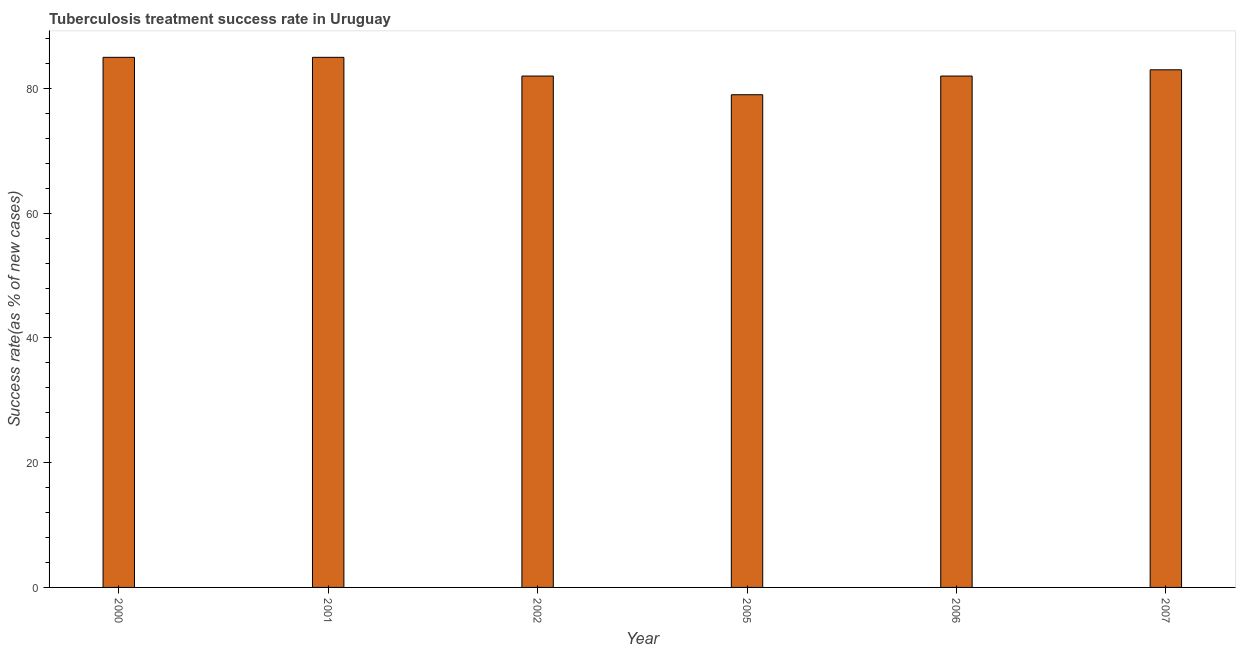Does the graph contain grids?
Provide a succinct answer. No. What is the title of the graph?
Keep it short and to the point. Tuberculosis treatment success rate in Uruguay. What is the label or title of the X-axis?
Offer a very short reply. Year. What is the label or title of the Y-axis?
Make the answer very short. Success rate(as % of new cases). What is the tuberculosis treatment success rate in 2007?
Provide a succinct answer. 83. Across all years, what is the maximum tuberculosis treatment success rate?
Your answer should be compact. 85. Across all years, what is the minimum tuberculosis treatment success rate?
Offer a very short reply. 79. In which year was the tuberculosis treatment success rate maximum?
Your answer should be compact. 2000. What is the sum of the tuberculosis treatment success rate?
Provide a short and direct response. 496. What is the average tuberculosis treatment success rate per year?
Your response must be concise. 82. What is the median tuberculosis treatment success rate?
Your answer should be very brief. 82.5. Is the tuberculosis treatment success rate in 2002 less than that in 2007?
Offer a terse response. Yes. Is the difference between the tuberculosis treatment success rate in 2001 and 2005 greater than the difference between any two years?
Make the answer very short. Yes. What is the difference between the highest and the second highest tuberculosis treatment success rate?
Keep it short and to the point. 0. How many bars are there?
Provide a succinct answer. 6. Are all the bars in the graph horizontal?
Ensure brevity in your answer.  No. How many years are there in the graph?
Your answer should be compact. 6. What is the difference between two consecutive major ticks on the Y-axis?
Your response must be concise. 20. Are the values on the major ticks of Y-axis written in scientific E-notation?
Ensure brevity in your answer.  No. What is the Success rate(as % of new cases) in 2002?
Offer a very short reply. 82. What is the Success rate(as % of new cases) in 2005?
Give a very brief answer. 79. What is the difference between the Success rate(as % of new cases) in 2000 and 2002?
Give a very brief answer. 3. What is the difference between the Success rate(as % of new cases) in 2001 and 2005?
Provide a succinct answer. 6. What is the difference between the Success rate(as % of new cases) in 2001 and 2007?
Your answer should be very brief. 2. What is the difference between the Success rate(as % of new cases) in 2002 and 2006?
Offer a terse response. 0. What is the difference between the Success rate(as % of new cases) in 2005 and 2007?
Provide a short and direct response. -4. What is the difference between the Success rate(as % of new cases) in 2006 and 2007?
Give a very brief answer. -1. What is the ratio of the Success rate(as % of new cases) in 2000 to that in 2001?
Make the answer very short. 1. What is the ratio of the Success rate(as % of new cases) in 2000 to that in 2002?
Offer a terse response. 1.04. What is the ratio of the Success rate(as % of new cases) in 2000 to that in 2005?
Offer a terse response. 1.08. What is the ratio of the Success rate(as % of new cases) in 2001 to that in 2002?
Your response must be concise. 1.04. What is the ratio of the Success rate(as % of new cases) in 2001 to that in 2005?
Offer a very short reply. 1.08. What is the ratio of the Success rate(as % of new cases) in 2002 to that in 2005?
Keep it short and to the point. 1.04. 